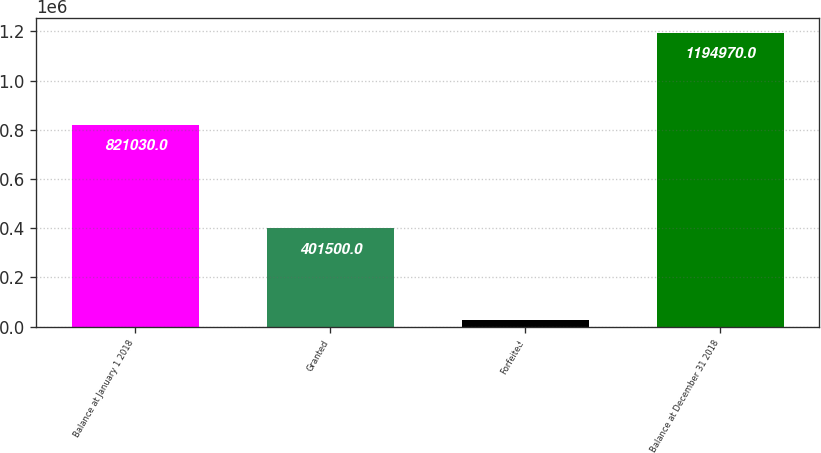Convert chart to OTSL. <chart><loc_0><loc_0><loc_500><loc_500><bar_chart><fcel>Balance at January 1 2018<fcel>Granted<fcel>Forfeited<fcel>Balance at December 31 2018<nl><fcel>821030<fcel>401500<fcel>27560<fcel>1.19497e+06<nl></chart> 